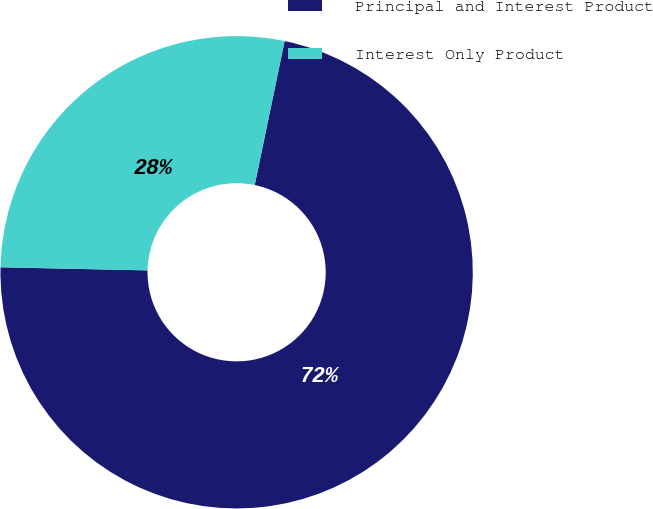<chart> <loc_0><loc_0><loc_500><loc_500><pie_chart><fcel>Principal and Interest Product<fcel>Interest Only Product<nl><fcel>72.08%<fcel>27.92%<nl></chart> 